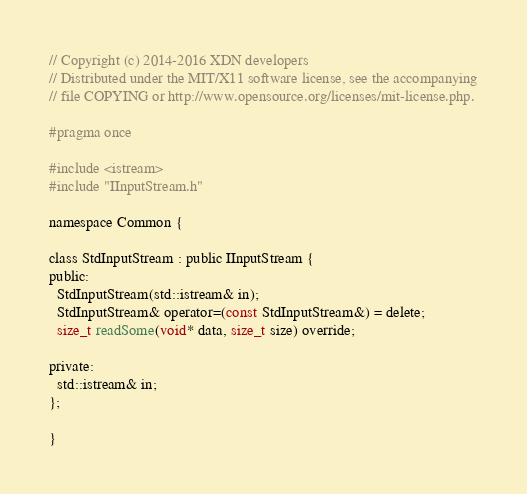Convert code to text. <code><loc_0><loc_0><loc_500><loc_500><_C_>
// Copyright (c) 2014-2016 XDN developers
// Distributed under the MIT/X11 software license, see the accompanying
// file COPYING or http://www.opensource.org/licenses/mit-license.php.

#pragma once

#include <istream>
#include "IInputStream.h"

namespace Common {

class StdInputStream : public IInputStream {
public:
  StdInputStream(std::istream& in);
  StdInputStream& operator=(const StdInputStream&) = delete;
  size_t readSome(void* data, size_t size) override;

private:
  std::istream& in;
};

}
</code> 